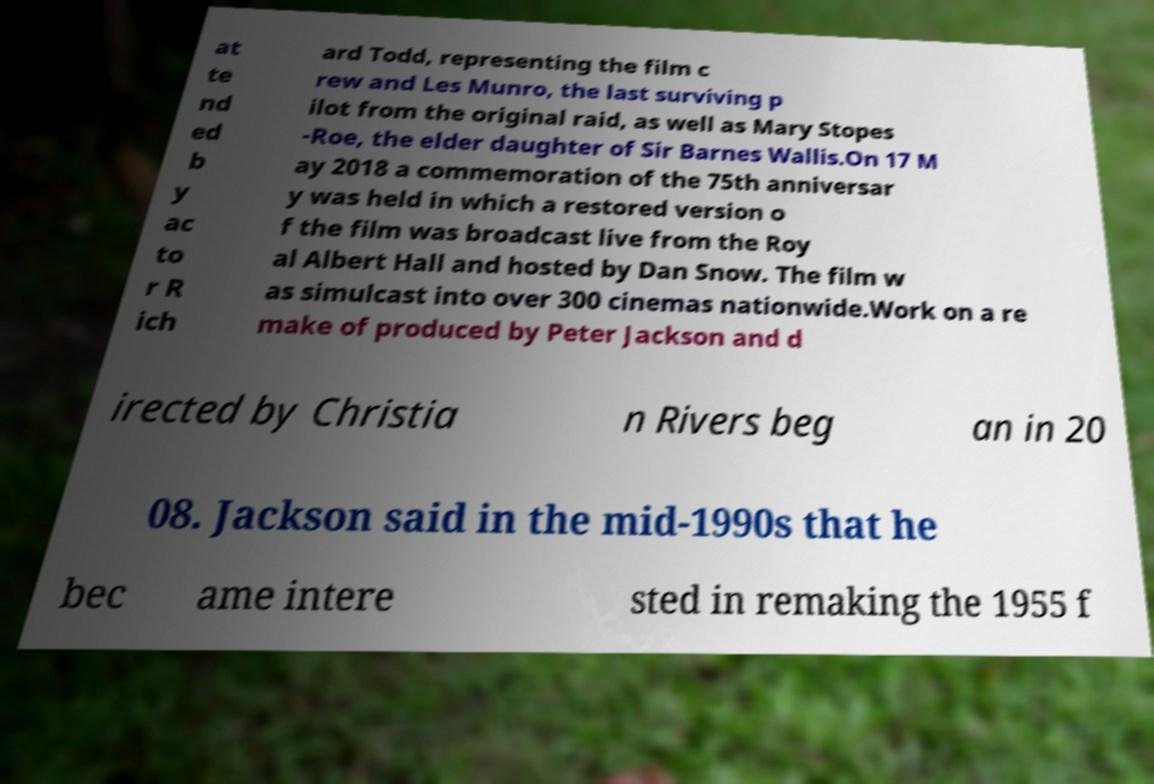Could you extract and type out the text from this image? at te nd ed b y ac to r R ich ard Todd, representing the film c rew and Les Munro, the last surviving p ilot from the original raid, as well as Mary Stopes -Roe, the elder daughter of Sir Barnes Wallis.On 17 M ay 2018 a commemoration of the 75th anniversar y was held in which a restored version o f the film was broadcast live from the Roy al Albert Hall and hosted by Dan Snow. The film w as simulcast into over 300 cinemas nationwide.Work on a re make of produced by Peter Jackson and d irected by Christia n Rivers beg an in 20 08. Jackson said in the mid-1990s that he bec ame intere sted in remaking the 1955 f 